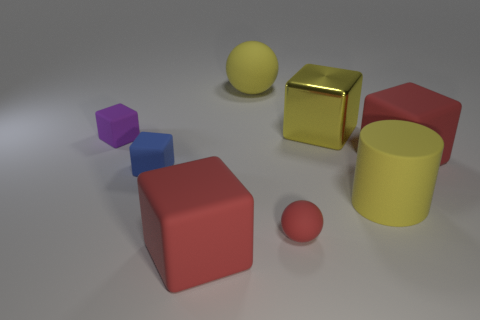Add 1 big green cylinders. How many objects exist? 9 Subtract all cylinders. How many objects are left? 7 Subtract all large green blocks. Subtract all small purple blocks. How many objects are left? 7 Add 1 red cubes. How many red cubes are left? 3 Add 2 large rubber spheres. How many large rubber spheres exist? 3 Subtract 0 cyan spheres. How many objects are left? 8 